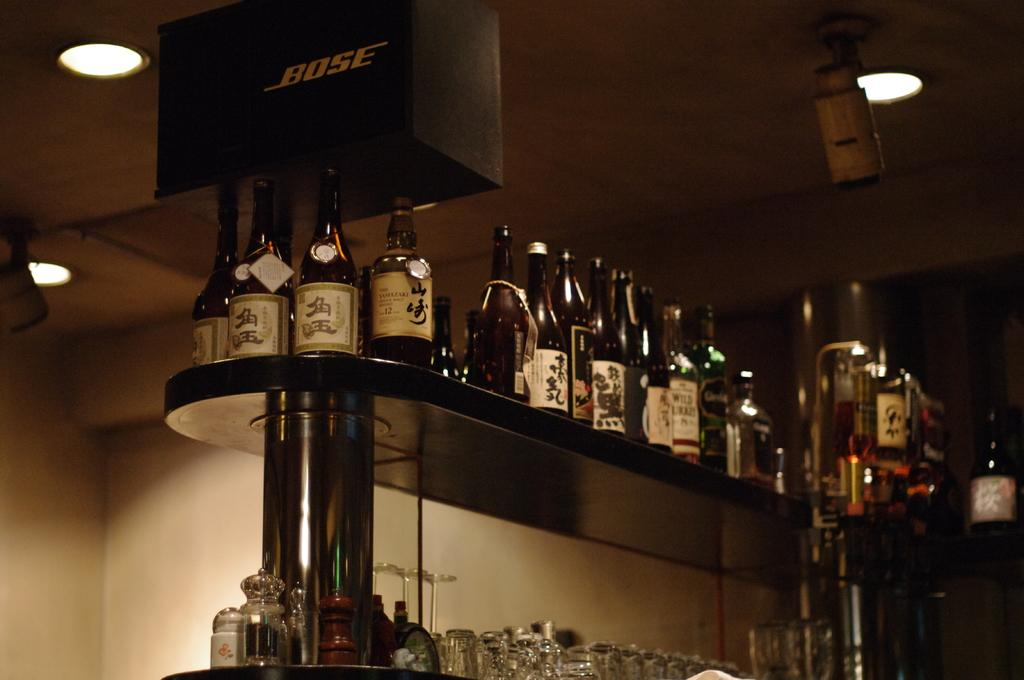Where is the image taken? The image is taken in a room. What objects can be seen on the shelf in the image? There are bottles, glasses, and a jar on the shelf in the image. What is the background of the bottles in the image? The background of the bottles is a shelf. What type of lighting is visible in the image? There are ceiling lights visible in the image. What color is the scarf worn by the frog in the image? There is no frog or scarf present in the image. What is the reason for the frog's presence in the image? There is no frog present in the image, so there is no reason for its presence. 